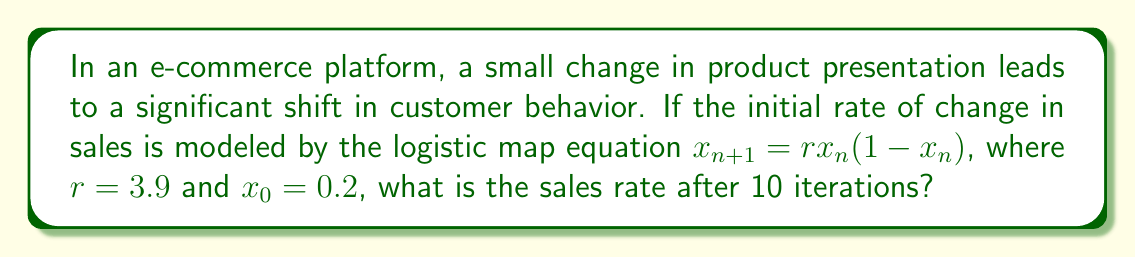What is the answer to this math problem? To solve this problem, we need to iterate the logistic map equation 10 times:

1) Start with $x_0 = 0.2$ and $r = 3.9$

2) For each iteration, calculate $x_{n+1} = rx_n(1-x_n)$:

   $x_1 = 3.9 * 0.2 * (1-0.2) = 0.624$
   $x_2 = 3.9 * 0.624 * (1-0.624) \approx 0.915789$
   $x_3 = 3.9 * 0.915789 * (1-0.915789) \approx 0.300846$
   $x_4 = 3.9 * 0.300846 * (1-0.300846) \approx 0.820718$
   $x_5 = 3.9 * 0.820718 * (1-0.820718) \approx 0.574425$
   $x_6 = 3.9 * 0.574425 * (1-0.574425) \approx 0.953353$
   $x_7 = 3.9 * 0.953353 * (1-0.953353) \approx 0.173929$
   $x_8 = 3.9 * 0.173929 * (1-0.173929) \approx 0.560512$
   $x_9 = 3.9 * 0.560512 * (1-0.560512) \approx 0.960736$
   $x_{10} = 3.9 * 0.960736 * (1-0.960736) \approx 0.147255$

3) The final value after 10 iterations is approximately 0.147255.

This demonstrates the butterfly effect in customer behavior, where a small initial change leads to unpredictable and significant variations over time.
Answer: 0.147255 